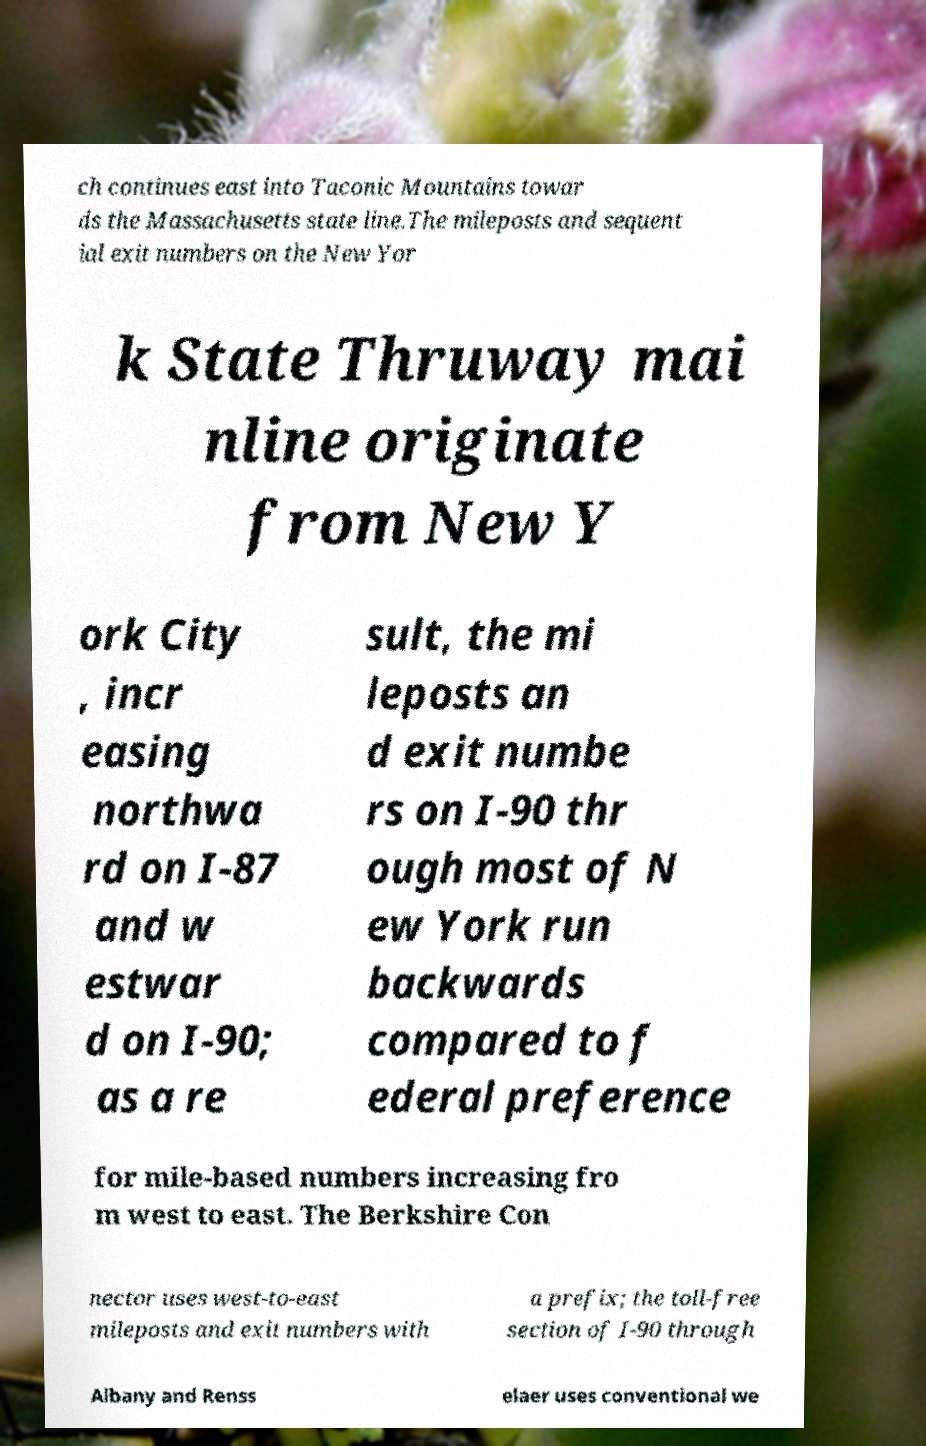Could you extract and type out the text from this image? ch continues east into Taconic Mountains towar ds the Massachusetts state line.The mileposts and sequent ial exit numbers on the New Yor k State Thruway mai nline originate from New Y ork City , incr easing northwa rd on I-87 and w estwar d on I-90; as a re sult, the mi leposts an d exit numbe rs on I-90 thr ough most of N ew York run backwards compared to f ederal preference for mile-based numbers increasing fro m west to east. The Berkshire Con nector uses west-to-east mileposts and exit numbers with a prefix; the toll-free section of I-90 through Albany and Renss elaer uses conventional we 